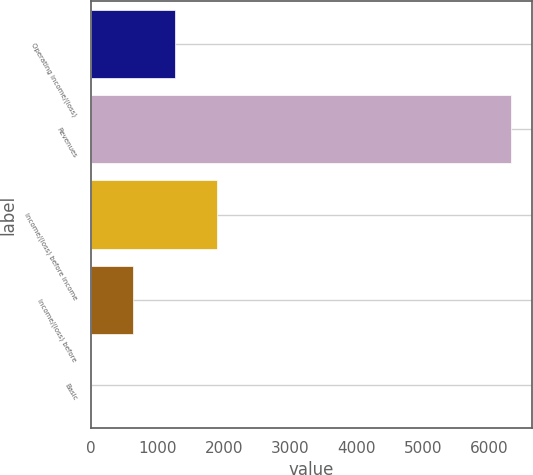<chart> <loc_0><loc_0><loc_500><loc_500><bar_chart><fcel>Operating income/(loss)<fcel>Revenues<fcel>Income/(loss) before income<fcel>Income/(loss) before<fcel>Basic<nl><fcel>1264.93<fcel>6324<fcel>1897.32<fcel>632.54<fcel>0.15<nl></chart> 